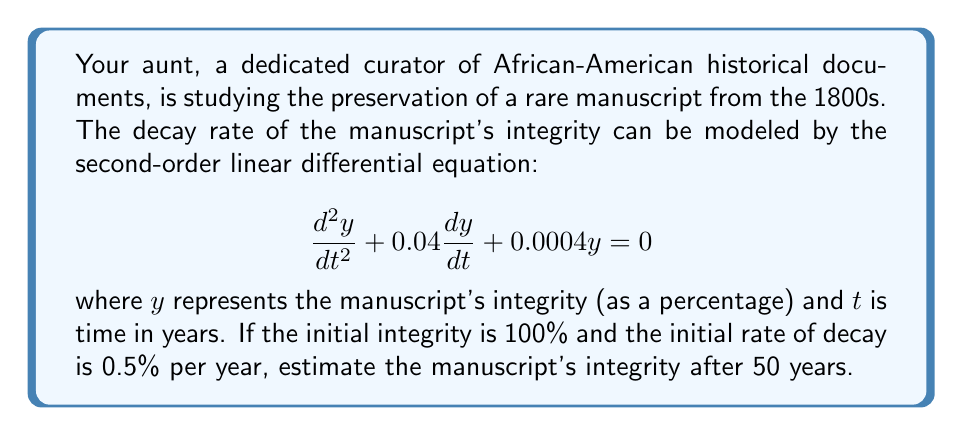What is the answer to this math problem? To solve this problem, we need to follow these steps:

1) The general solution for this second-order linear differential equation is:

   $$y = C_1e^{r_1t} + C_2e^{r_2t}$$

   where $r_1$ and $r_2$ are the roots of the characteristic equation.

2) The characteristic equation is:
   
   $$r^2 + 0.04r + 0.0004 = 0$$

3) Solving this quadratic equation:
   
   $$r = \frac{-0.04 \pm \sqrt{0.04^2 - 4(1)(0.0004)}}{2(1)} = -0.02 \pm 0.01$$

   So, $r_1 = -0.01$ and $r_2 = -0.03$

4) Our general solution is now:

   $$y = C_1e^{-0.01t} + C_2e^{-0.03t}$$

5) We use the initial conditions to find $C_1$ and $C_2$:
   
   At $t=0$, $y=100$, so:
   $$100 = C_1 + C_2$$

   The initial rate of decay is 0.5% per year, so $\frac{dy}{dt} = -0.5$ at $t=0$:
   $$-0.5 = -0.01C_1 - 0.03C_2$$

6) Solving these equations:
   
   $C_1 = 75$ and $C_2 = 25$

7) Our particular solution is:

   $$y = 75e^{-0.01t} + 25e^{-0.03t}$$

8) To find the integrity after 50 years, we substitute $t=50$:

   $$y = 75e^{-0.01(50)} + 25e^{-0.03(50)} \approx 68.10 + 6.77 = 74.87$$
Answer: After 50 years, the manuscript's integrity will be approximately 74.87% of its original condition. 